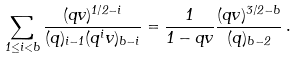<formula> <loc_0><loc_0><loc_500><loc_500>\sum _ { 1 \leq i < b } \frac { ( q v ) ^ { 1 / 2 - i } } { ( q ) _ { i - 1 } ( q ^ { i } v ) _ { b - i } } = \frac { 1 } { 1 - q v } \frac { ( q v ) ^ { 3 / 2 - b } } { ( q ) _ { b - 2 } } \, .</formula> 